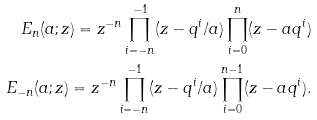Convert formula to latex. <formula><loc_0><loc_0><loc_500><loc_500>E _ { n } ( a ; z ) = z ^ { - n } \prod _ { i = - n } ^ { - 1 } ( z - q ^ { i } / a ) \prod _ { i = 0 } ^ { n } ( z - a q ^ { i } ) \\ E _ { - n } ( a ; z ) = z ^ { - n } \prod _ { i = - n } ^ { - 1 } ( z - q ^ { i } / a ) \prod _ { i = 0 } ^ { n - 1 } ( z - a q ^ { i } ) .</formula> 